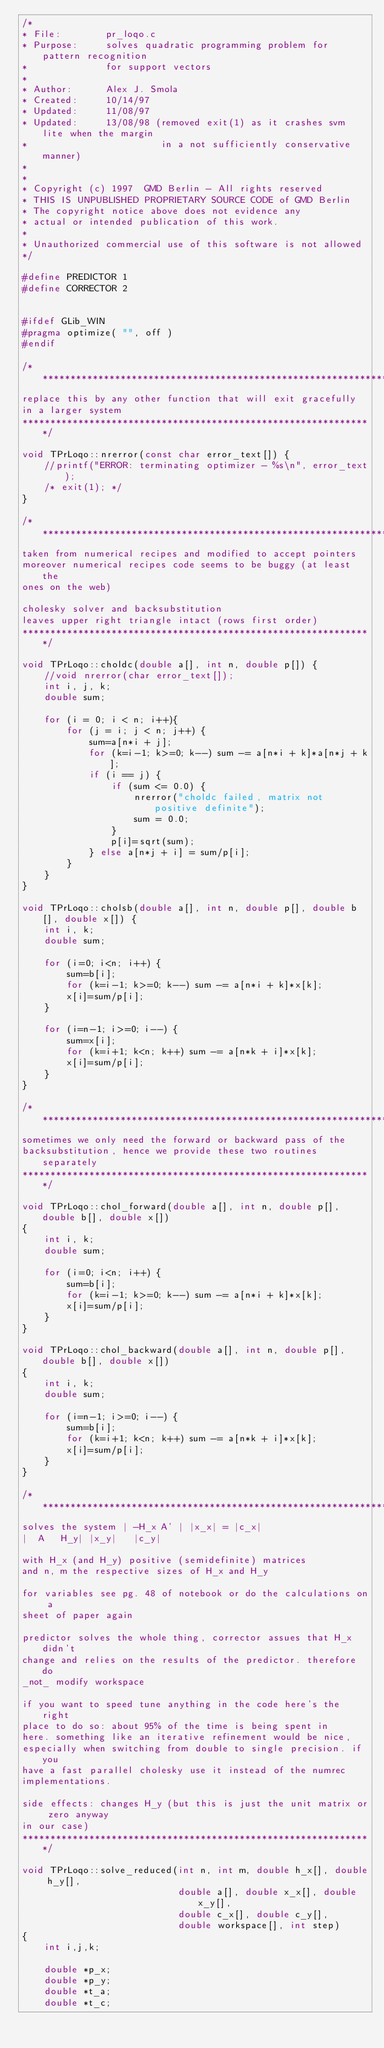<code> <loc_0><loc_0><loc_500><loc_500><_C++_>/*
* File:        pr_loqo.c
* Purpose:     solves quadratic programming problem for pattern recognition
*              for support vectors
*
* Author:      Alex J. Smola
* Created:     10/14/97
* Updated:     11/08/97
* Updated:     13/08/98 (removed exit(1) as it crashes svm lite when the margin
*                        in a not sufficiently conservative manner)
*
* 
* Copyright (c) 1997  GMD Berlin - All rights reserved
* THIS IS UNPUBLISHED PROPRIETARY SOURCE CODE of GMD Berlin
* The copyright notice above does not evidence any
* actual or intended publication of this work.
*
* Unauthorized commercial use of this software is not allowed
*/

#define PREDICTOR 1
#define CORRECTOR 2

 
#ifdef GLib_WIN
#pragma optimize( "", off )
#endif
 
/*****************************************************************
replace this by any other function that will exit gracefully
in a larger system
***************************************************************/

void TPrLoqo::nrerror(const char error_text[]) {
    //printf("ERROR: terminating optimizer - %s\n", error_text);
    /* exit(1); */
}

/*****************************************************************
taken from numerical recipes and modified to accept pointers
moreover numerical recipes code seems to be buggy (at least the
ones on the web)

cholesky solver and backsubstitution
leaves upper right triangle intact (rows first order)
***************************************************************/

void TPrLoqo::choldc(double a[], int n, double p[]) {
    //void nrerror(char error_text[]);
    int i, j, k;
    double sum;

    for (i = 0; i < n; i++){
        for (j = i; j < n; j++) {
            sum=a[n*i + j];
            for (k=i-1; k>=0; k--) sum -= a[n*i + k]*a[n*j + k];
            if (i == j) {
                if (sum <= 0.0) {
                    nrerror("choldc failed, matrix not positive definite");
                    sum = 0.0;
                }
                p[i]=sqrt(sum);
            } else a[n*j + i] = sum/p[i];
        }
    }
}

void TPrLoqo::cholsb(double a[], int n, double p[], double b[], double x[]) {
    int i, k;
    double sum;

    for (i=0; i<n; i++) {
        sum=b[i];
        for (k=i-1; k>=0; k--) sum -= a[n*i + k]*x[k];
        x[i]=sum/p[i];
    }

    for (i=n-1; i>=0; i--) {
        sum=x[i];
        for (k=i+1; k<n; k++) sum -= a[n*k + i]*x[k];
        x[i]=sum/p[i];
    }
}

/*****************************************************************
sometimes we only need the forward or backward pass of the
backsubstitution, hence we provide these two routines separately 
***************************************************************/

void TPrLoqo::chol_forward(double a[], int n, double p[], double b[], double x[])
{
    int i, k;
    double sum;

    for (i=0; i<n; i++) {
        sum=b[i];
        for (k=i-1; k>=0; k--) sum -= a[n*i + k]*x[k];
        x[i]=sum/p[i];
    }
}

void TPrLoqo::chol_backward(double a[], int n, double p[], double b[], double x[])
{
    int i, k;
    double sum;

    for (i=n-1; i>=0; i--) {
        sum=b[i];
        for (k=i+1; k<n; k++) sum -= a[n*k + i]*x[k];
        x[i]=sum/p[i];
    }
}

/*****************************************************************
solves the system | -H_x A' | |x_x| = |c_x|
|  A   H_y| |x_y|   |c_y|

with H_x (and H_y) positive (semidefinite) matrices
and n, m the respective sizes of H_x and H_y

for variables see pg. 48 of notebook or do the calculations on a
sheet of paper again

predictor solves the whole thing, corrector assues that H_x didn't
change and relies on the results of the predictor. therefore do
_not_ modify workspace

if you want to speed tune anything in the code here's the right
place to do so: about 95% of the time is being spent in
here. something like an iterative refinement would be nice,
especially when switching from double to single precision. if you
have a fast parallel cholesky use it instead of the numrec
implementations.

side effects: changes H_y (but this is just the unit matrix or zero anyway
in our case)
***************************************************************/

void TPrLoqo::solve_reduced(int n, int m, double h_x[], double h_y[], 
                            double a[], double x_x[], double x_y[],
                            double c_x[], double c_y[],
                            double workspace[], int step)
{
    int i,j,k;

    double *p_x;
    double *p_y;
    double *t_a;
    double *t_c;</code> 